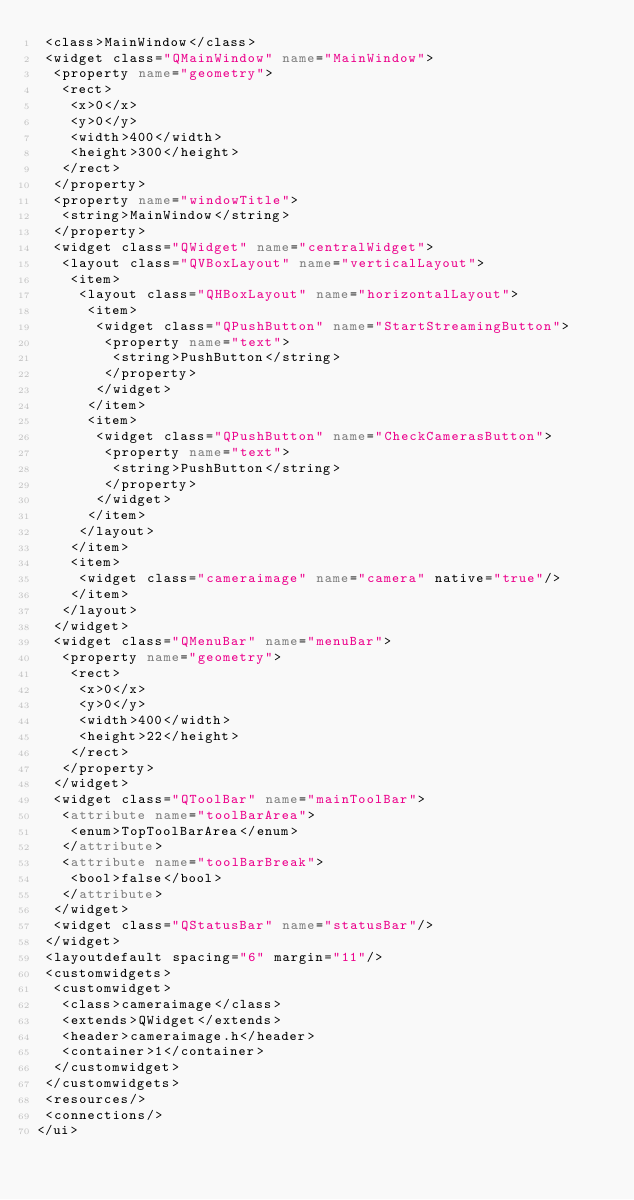<code> <loc_0><loc_0><loc_500><loc_500><_XML_> <class>MainWindow</class>
 <widget class="QMainWindow" name="MainWindow">
  <property name="geometry">
   <rect>
    <x>0</x>
    <y>0</y>
    <width>400</width>
    <height>300</height>
   </rect>
  </property>
  <property name="windowTitle">
   <string>MainWindow</string>
  </property>
  <widget class="QWidget" name="centralWidget">
   <layout class="QVBoxLayout" name="verticalLayout">
    <item>
     <layout class="QHBoxLayout" name="horizontalLayout">
      <item>
       <widget class="QPushButton" name="StartStreamingButton">
        <property name="text">
         <string>PushButton</string>
        </property>
       </widget>
      </item>
      <item>
       <widget class="QPushButton" name="CheckCamerasButton">
        <property name="text">
         <string>PushButton</string>
        </property>
       </widget>
      </item>
     </layout>
    </item>
    <item>
     <widget class="cameraimage" name="camera" native="true"/>
    </item>
   </layout>
  </widget>
  <widget class="QMenuBar" name="menuBar">
   <property name="geometry">
    <rect>
     <x>0</x>
     <y>0</y>
     <width>400</width>
     <height>22</height>
    </rect>
   </property>
  </widget>
  <widget class="QToolBar" name="mainToolBar">
   <attribute name="toolBarArea">
    <enum>TopToolBarArea</enum>
   </attribute>
   <attribute name="toolBarBreak">
    <bool>false</bool>
   </attribute>
  </widget>
  <widget class="QStatusBar" name="statusBar"/>
 </widget>
 <layoutdefault spacing="6" margin="11"/>
 <customwidgets>
  <customwidget>
   <class>cameraimage</class>
   <extends>QWidget</extends>
   <header>cameraimage.h</header>
   <container>1</container>
  </customwidget>
 </customwidgets>
 <resources/>
 <connections/>
</ui>
</code> 